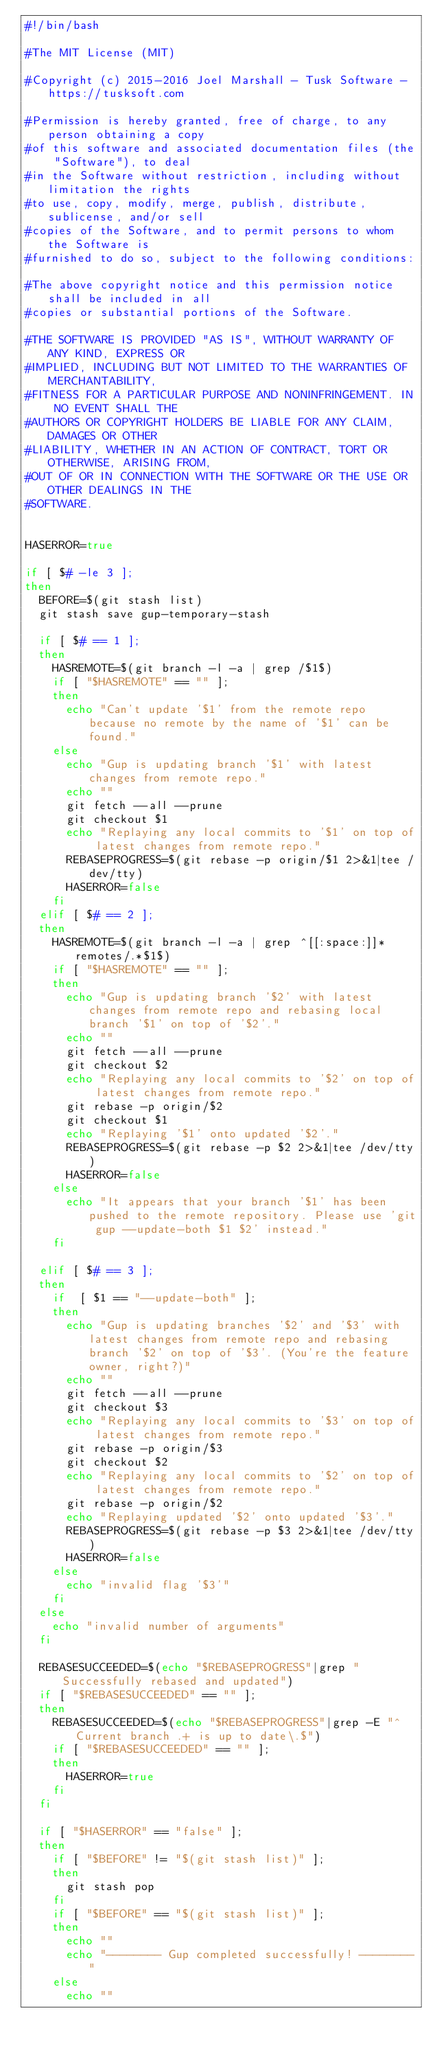Convert code to text. <code><loc_0><loc_0><loc_500><loc_500><_Bash_>#!/bin/bash

#The MIT License (MIT)

#Copyright (c) 2015-2016 Joel Marshall - Tusk Software - https://tusksoft.com

#Permission is hereby granted, free of charge, to any person obtaining a copy
#of this software and associated documentation files (the "Software"), to deal
#in the Software without restriction, including without limitation the rights
#to use, copy, modify, merge, publish, distribute, sublicense, and/or sell
#copies of the Software, and to permit persons to whom the Software is
#furnished to do so, subject to the following conditions:

#The above copyright notice and this permission notice shall be included in all
#copies or substantial portions of the Software.

#THE SOFTWARE IS PROVIDED "AS IS", WITHOUT WARRANTY OF ANY KIND, EXPRESS OR
#IMPLIED, INCLUDING BUT NOT LIMITED TO THE WARRANTIES OF MERCHANTABILITY,
#FITNESS FOR A PARTICULAR PURPOSE AND NONINFRINGEMENT. IN NO EVENT SHALL THE
#AUTHORS OR COPYRIGHT HOLDERS BE LIABLE FOR ANY CLAIM, DAMAGES OR OTHER
#LIABILITY, WHETHER IN AN ACTION OF CONTRACT, TORT OR OTHERWISE, ARISING FROM,
#OUT OF OR IN CONNECTION WITH THE SOFTWARE OR THE USE OR OTHER DEALINGS IN THE
#SOFTWARE.


HASERROR=true

if [ $# -le 3 ];
then
	BEFORE=$(git stash list)
	git stash save gup-temporary-stash

	if [ $# == 1 ];
	then
		HASREMOTE=$(git branch -l -a | grep /$1$)
		if [ "$HASREMOTE" == "" ];
		then
			echo "Can't update '$1' from the remote repo because no remote by the name of '$1' can be found."
		else
			echo "Gup is updating branch '$1' with latest changes from remote repo."
			echo ""
			git fetch --all --prune
			git checkout $1
			echo "Replaying any local commits to '$1' on top of latest changes from remote repo."
			REBASEPROGRESS=$(git rebase -p origin/$1 2>&1|tee /dev/tty)
			HASERROR=false
		fi
	elif [ $# == 2 ];
	then
		HASREMOTE=$(git branch -l -a | grep ^[[:space:]]*remotes/.*$1$)
		if [ "$HASREMOTE" == "" ];
		then
			echo "Gup is updating branch '$2' with latest changes from remote repo and rebasing local branch '$1' on top of '$2'."
			echo ""
			git fetch --all --prune
			git checkout $2
			echo "Replaying any local commits to '$2' on top of latest changes from remote repo."
			git rebase -p origin/$2 
			git checkout $1
			echo "Replaying '$1' onto updated '$2'."
			REBASEPROGRESS=$(git rebase -p $2 2>&1|tee /dev/tty)
			HASERROR=false
		else
			echo "It appears that your branch '$1' has been pushed to the remote repository. Please use 'git gup --update-both $1 $2' instead."
		fi

	elif [ $# == 3 ];
	then
		if  [ $1 == "--update-both" ];
		then
			echo "Gup is updating branches '$2' and '$3' with latest changes from remote repo and rebasing branch '$2' on top of '$3'. (You're the feature owner, right?)"
			echo ""
			git fetch --all --prune
			git checkout $3
			echo "Replaying any local commits to '$3' on top of latest changes from remote repo."
			git rebase -p origin/$3
			git checkout $2
			echo "Replaying any local commits to '$2' on top of latest changes from remote repo."
			git rebase -p origin/$2 
			echo "Replaying updated '$2' onto updated '$3'."
			REBASEPROGRESS=$(git rebase -p $3 2>&1|tee /dev/tty)
			HASERROR=false
		else
			echo "invalid flag '$3'"
		fi
	else
		echo "invalid number of arguments"	
	fi
	
	REBASESUCCEEDED=$(echo "$REBASEPROGRESS"|grep "Successfully rebased and updated")
	if [ "$REBASESUCCEEDED" == "" ];
	then
		REBASESUCCEEDED=$(echo "$REBASEPROGRESS"|grep -E "^Current branch .+ is up to date\.$")
		if [ "$REBASESUCCEEDED" == "" ];
		then
			HASERROR=true
		fi	
	fi
	
	if [ "$HASERROR" == "false" ];
	then
		if [ "$BEFORE" != "$(git stash list)" ]; 
		then
			git stash pop
		fi
		if [ "$BEFORE" == "$(git stash list)" ]; 
		then
			echo ""
			echo "-------- Gup completed successfully! --------"
		else
			echo ""</code> 